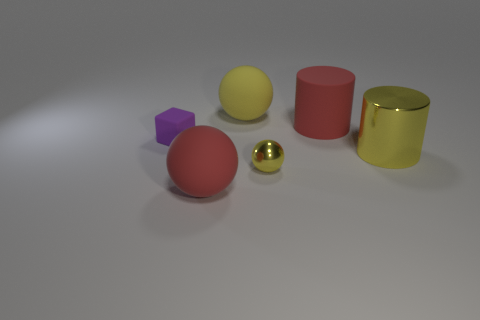How many rubber things are right of the tiny rubber object and on the left side of the red cylinder?
Ensure brevity in your answer.  2. The other matte thing that is the same shape as the yellow matte thing is what color?
Ensure brevity in your answer.  Red. Is the number of small yellow metallic balls less than the number of big green cylinders?
Ensure brevity in your answer.  No. Do the yellow rubber ball and the cylinder that is behind the small rubber cube have the same size?
Your response must be concise. Yes. There is a large matte sphere that is behind the large yellow object on the right side of the large red cylinder; what is its color?
Offer a terse response. Yellow. What number of objects are either large matte things in front of the yellow cylinder or spheres in front of the big yellow cylinder?
Offer a very short reply. 2. Does the red rubber ball have the same size as the yellow metallic cylinder?
Give a very brief answer. Yes. There is a big red rubber thing behind the small purple rubber block; is it the same shape as the yellow shiny thing to the right of the big rubber cylinder?
Make the answer very short. Yes. The red matte cylinder is what size?
Your answer should be compact. Large. There is a yellow ball behind the purple cube in front of the thing that is behind the red matte cylinder; what is it made of?
Provide a short and direct response. Rubber. 